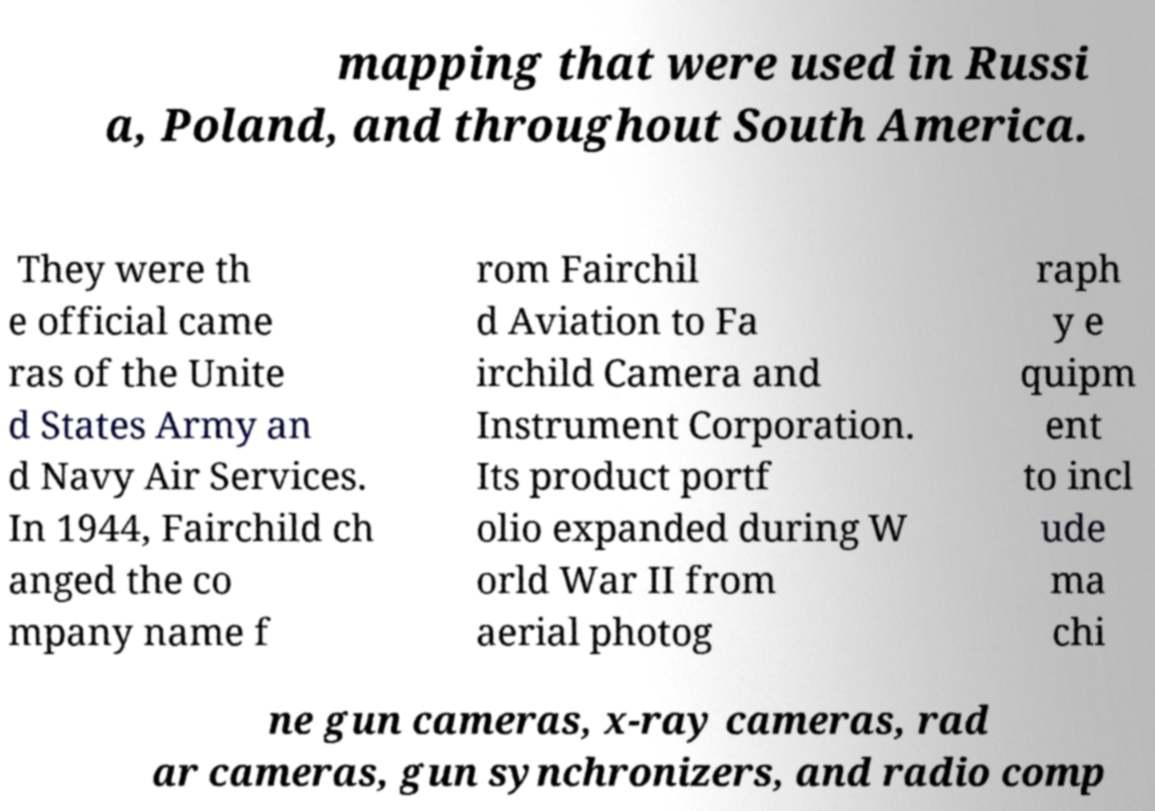There's text embedded in this image that I need extracted. Can you transcribe it verbatim? mapping that were used in Russi a, Poland, and throughout South America. They were th e official came ras of the Unite d States Army an d Navy Air Services. In 1944, Fairchild ch anged the co mpany name f rom Fairchil d Aviation to Fa irchild Camera and Instrument Corporation. Its product portf olio expanded during W orld War II from aerial photog raph y e quipm ent to incl ude ma chi ne gun cameras, x-ray cameras, rad ar cameras, gun synchronizers, and radio comp 